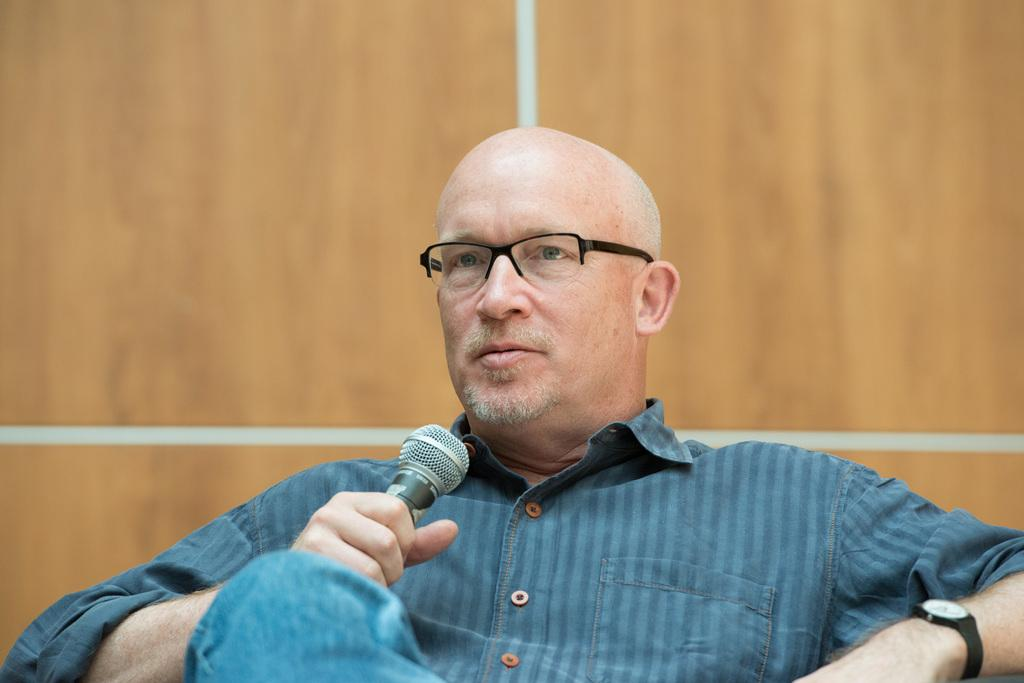What is the main subject of the image? There is a man in the image. What is the man wearing? The man is wearing a blue shirt and blue jeans. What is the man holding in the image? The man is holding a mic. What color is the wall in the background of the image? There is a brown-colored wall in the background of the image. What type of oatmeal is being served on the unit in the image? There is no oatmeal or unit present in the image; it features a man holding a mic with a brown-colored wall in the background. How many fifths are visible in the image? There are no fifths present in the image. 